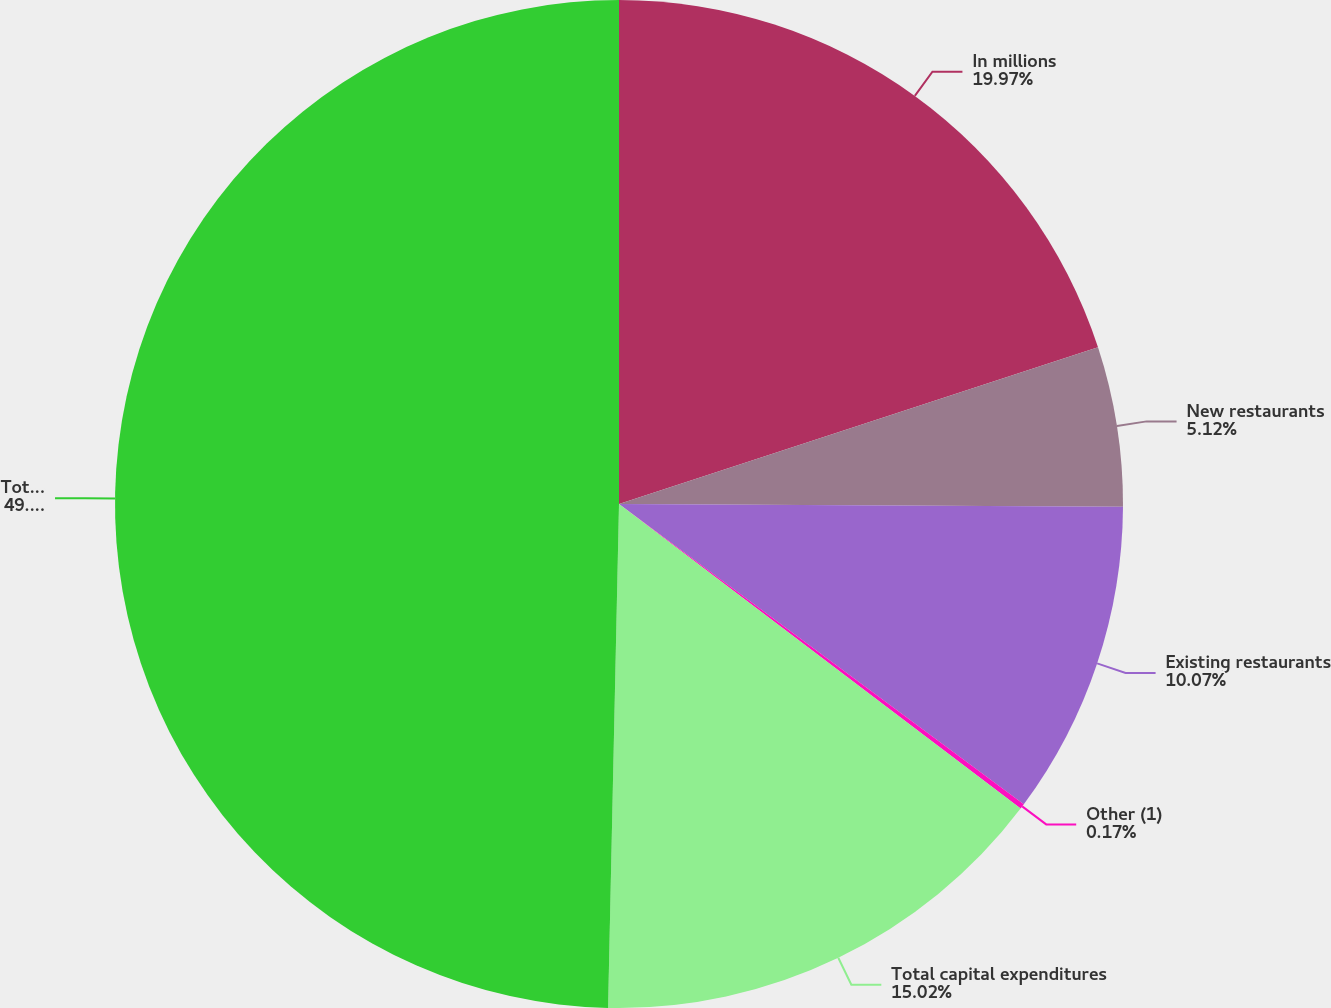<chart> <loc_0><loc_0><loc_500><loc_500><pie_chart><fcel>In millions<fcel>New restaurants<fcel>Existing restaurants<fcel>Other (1)<fcel>Total capital expenditures<fcel>Total assets<nl><fcel>19.97%<fcel>5.12%<fcel>10.07%<fcel>0.17%<fcel>15.02%<fcel>49.66%<nl></chart> 